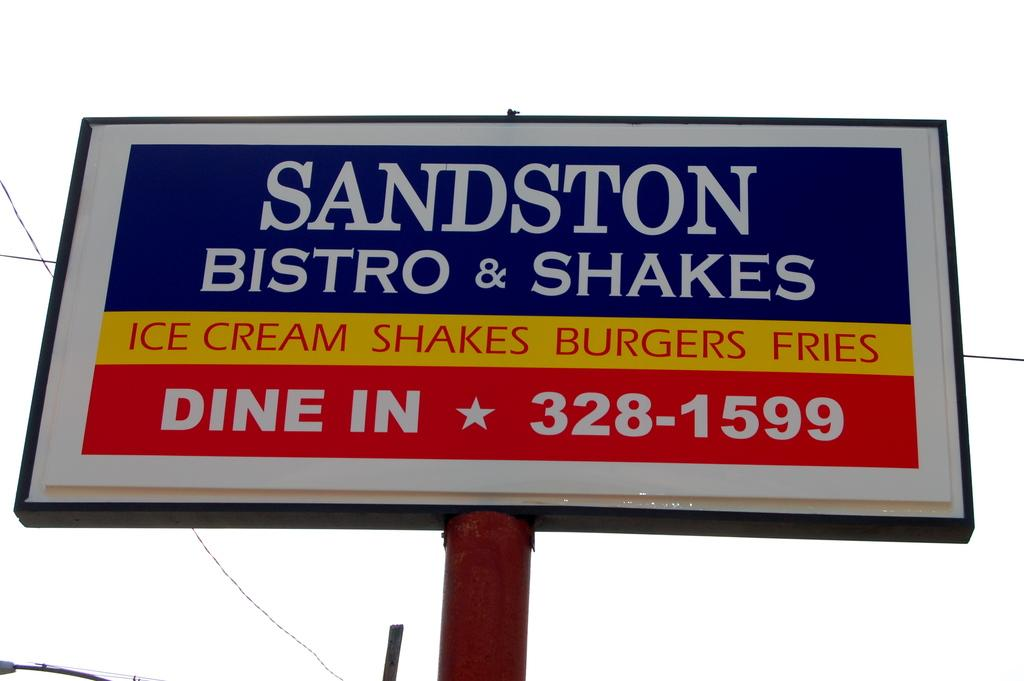<image>
Render a clear and concise summary of the photo. Large sign that says "Sandston Bistro & Shakes" towards the top. 